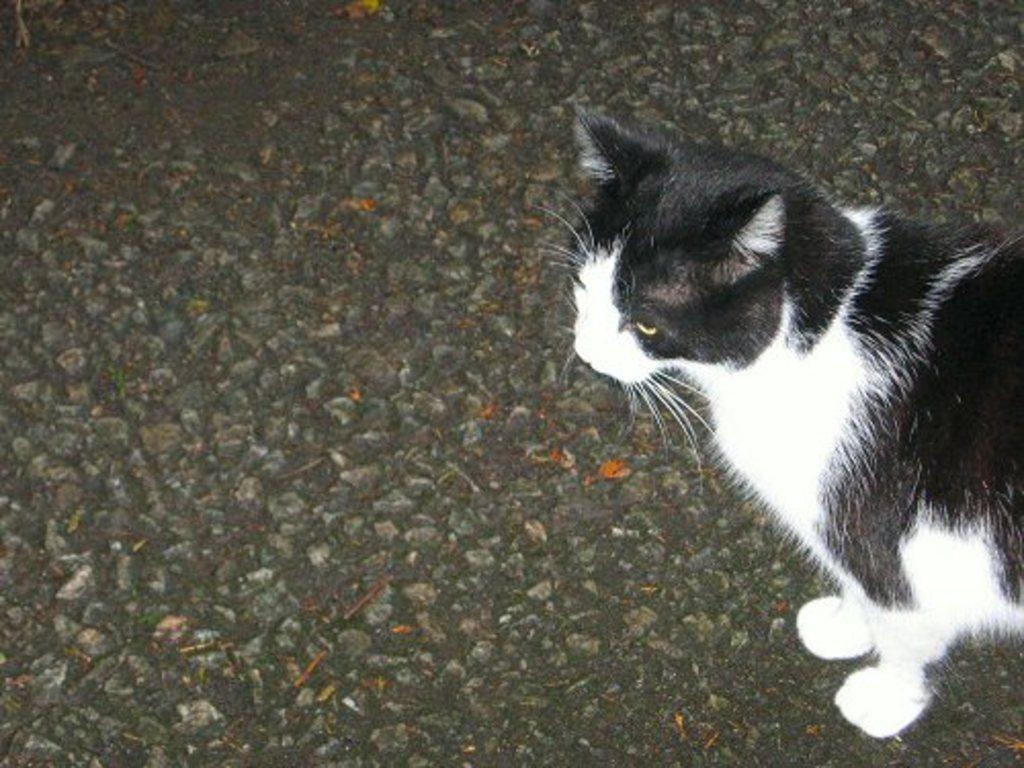Describe this image in one or two sentences. In this image we can see a black and white color cat on the black color surface. 